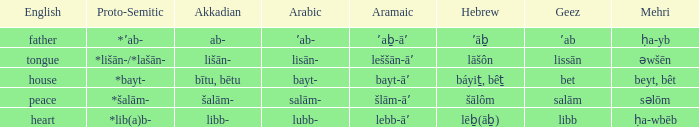If the proto-semitic is *bayt-, what are the geez? Bet. 